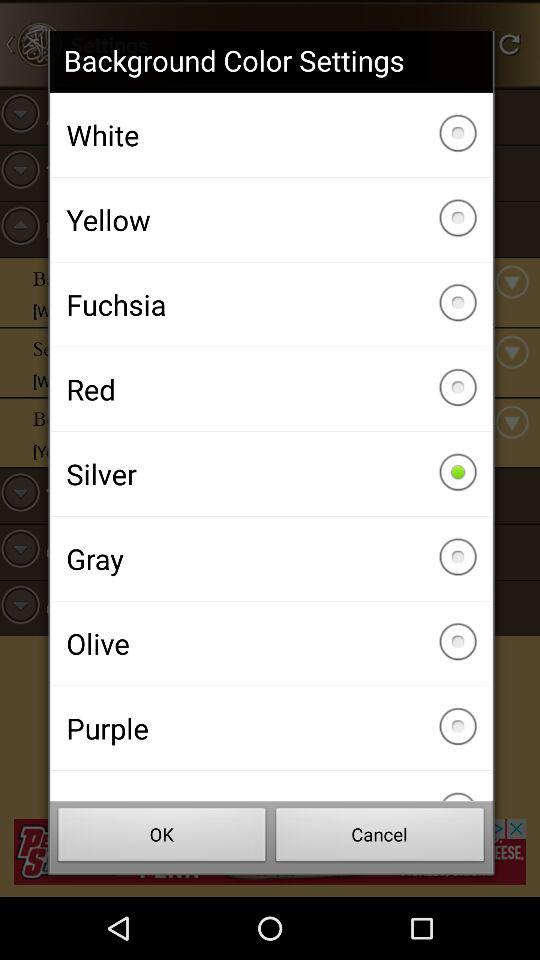How many colors are available in the background color settings?
Answer the question using a single word or phrase. 8 